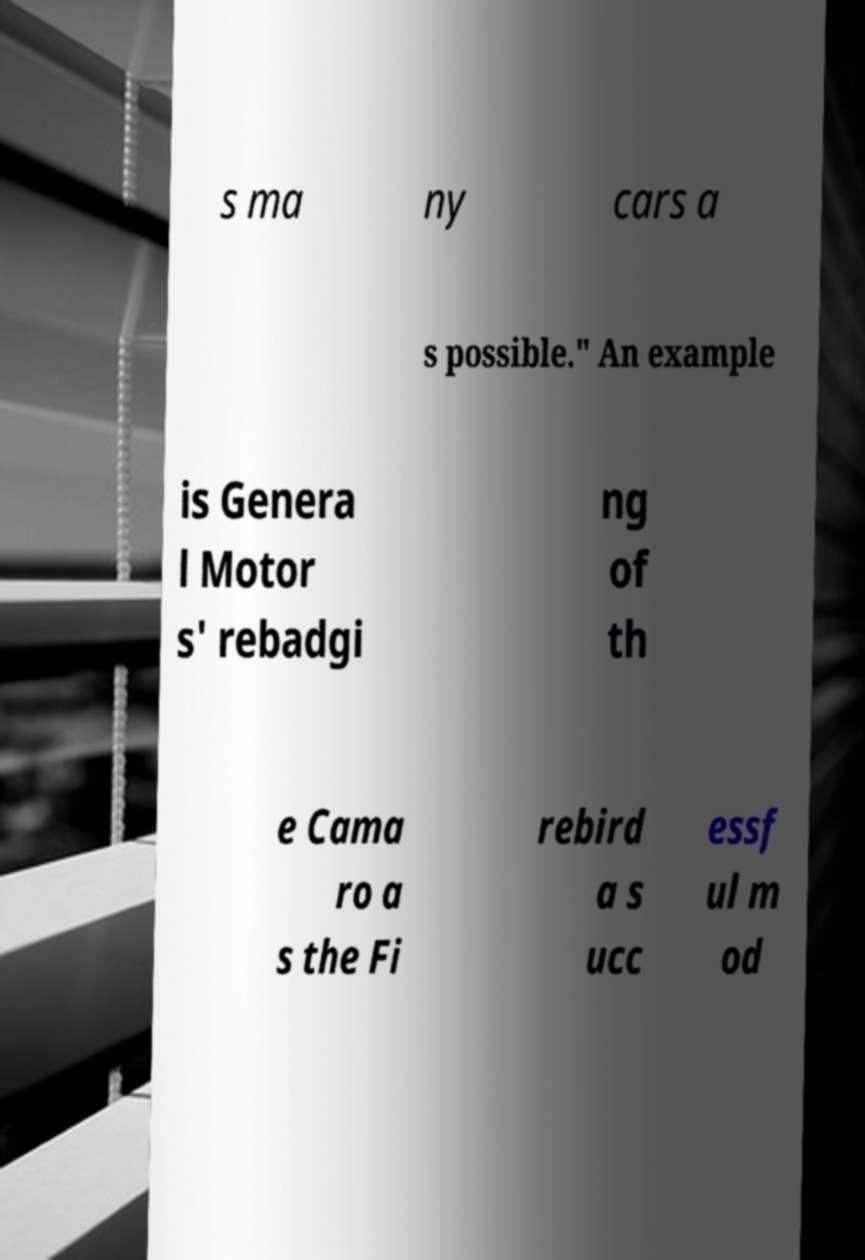I need the written content from this picture converted into text. Can you do that? s ma ny cars a s possible." An example is Genera l Motor s' rebadgi ng of th e Cama ro a s the Fi rebird a s ucc essf ul m od 